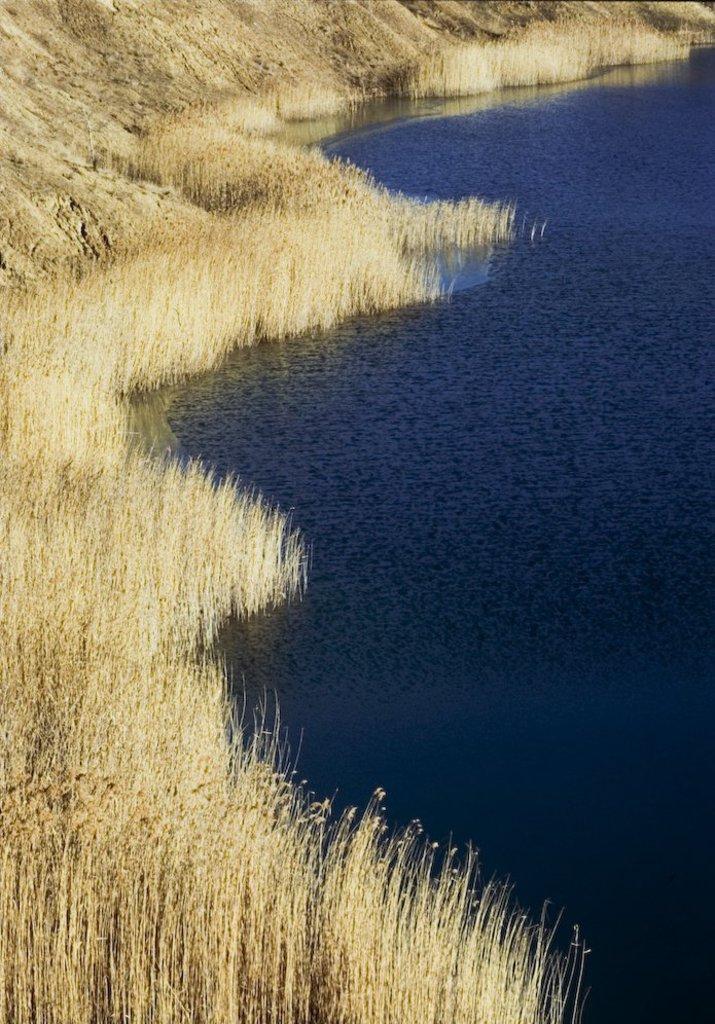How would you summarize this image in a sentence or two? In this image there is a river at right side of this image and there is some grass at left side of this image. 